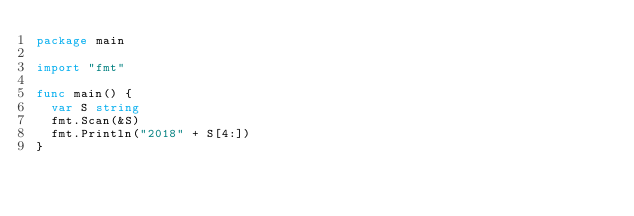Convert code to text. <code><loc_0><loc_0><loc_500><loc_500><_Go_>package main

import "fmt"

func main() {
	var S string
	fmt.Scan(&S)
	fmt.Println("2018" + S[4:])
}</code> 